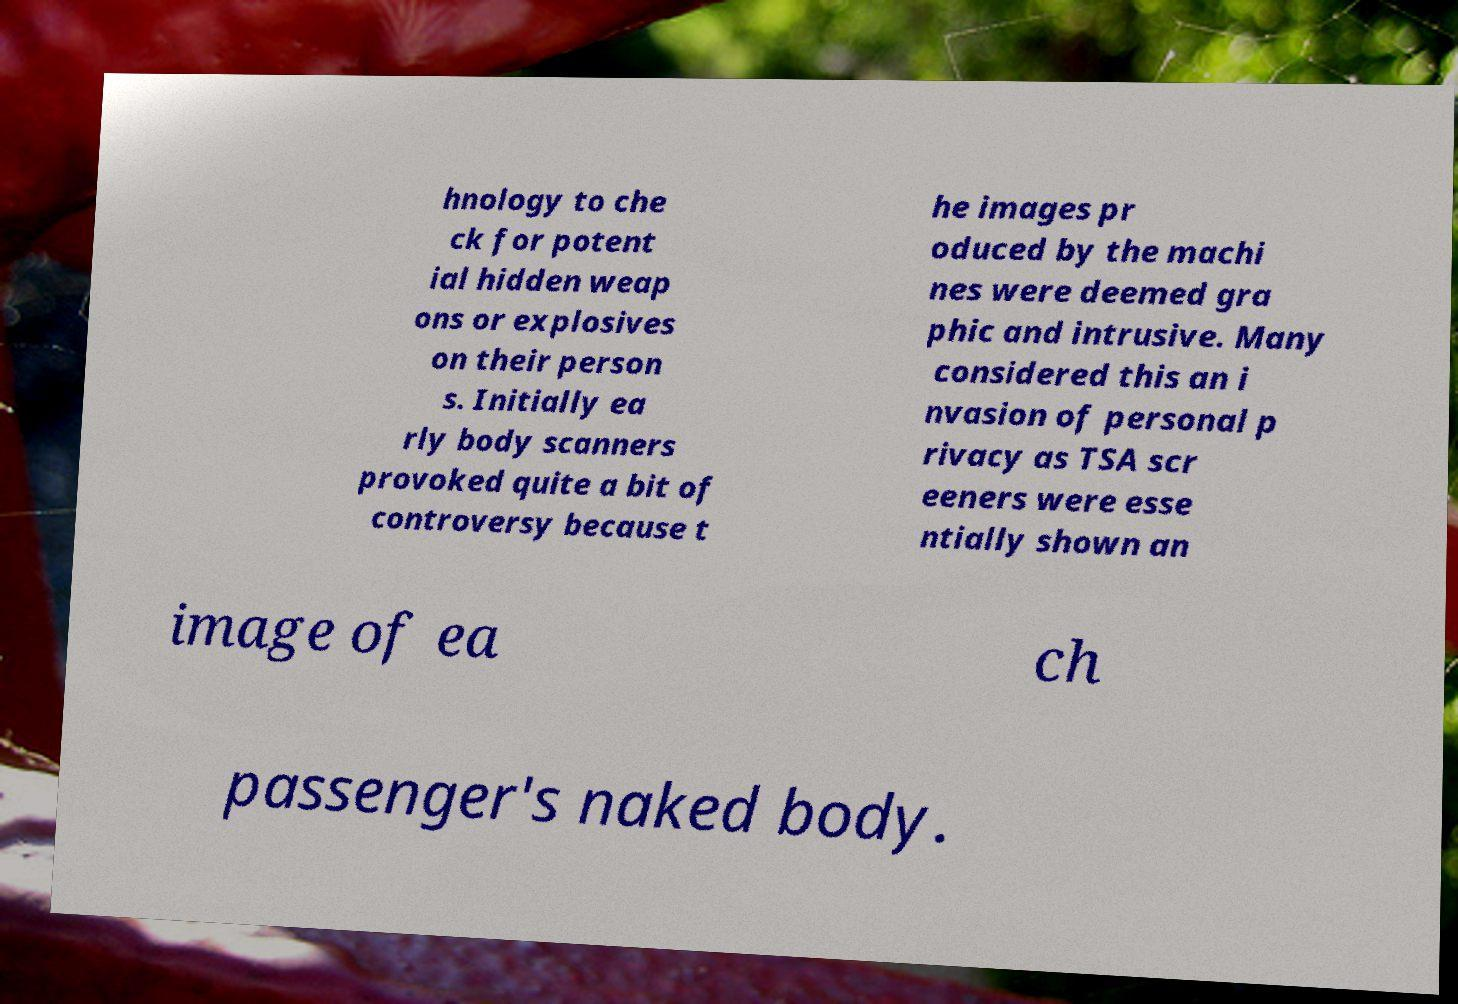Please read and relay the text visible in this image. What does it say? hnology to che ck for potent ial hidden weap ons or explosives on their person s. Initially ea rly body scanners provoked quite a bit of controversy because t he images pr oduced by the machi nes were deemed gra phic and intrusive. Many considered this an i nvasion of personal p rivacy as TSA scr eeners were esse ntially shown an image of ea ch passenger's naked body. 